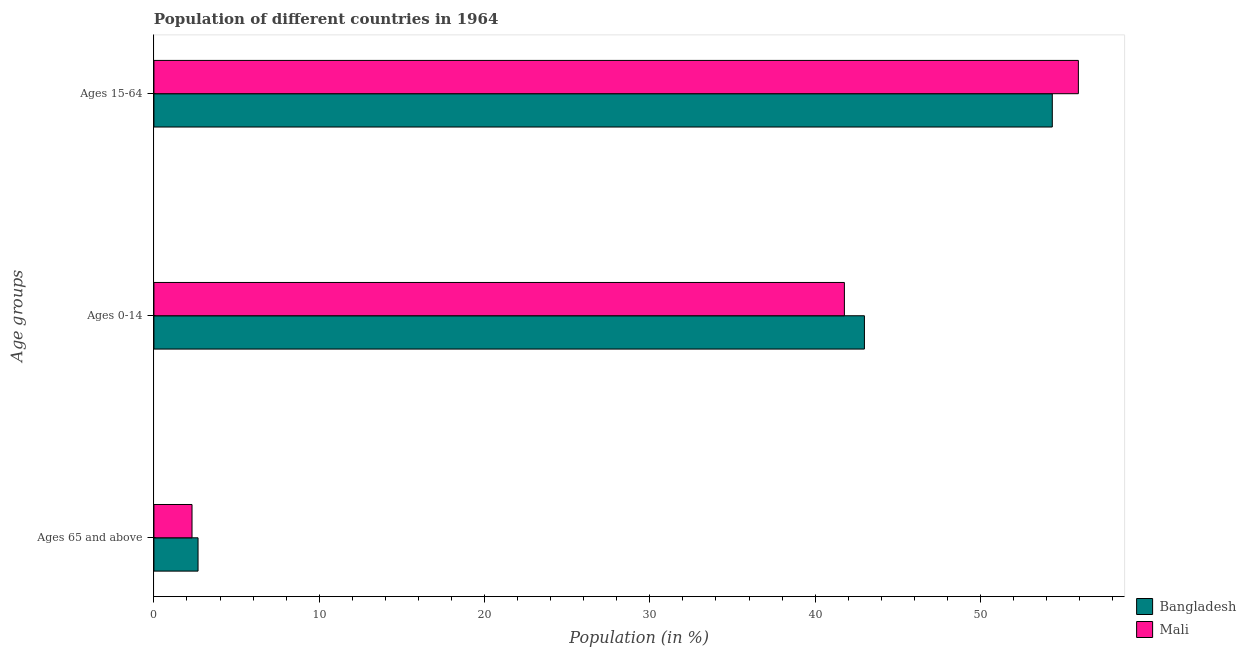Are the number of bars on each tick of the Y-axis equal?
Keep it short and to the point. Yes. How many bars are there on the 1st tick from the top?
Keep it short and to the point. 2. How many bars are there on the 2nd tick from the bottom?
Make the answer very short. 2. What is the label of the 1st group of bars from the top?
Offer a terse response. Ages 15-64. What is the percentage of population within the age-group 0-14 in Bangladesh?
Your answer should be very brief. 42.98. Across all countries, what is the maximum percentage of population within the age-group of 65 and above?
Your answer should be very brief. 2.67. Across all countries, what is the minimum percentage of population within the age-group of 65 and above?
Give a very brief answer. 2.3. In which country was the percentage of population within the age-group 0-14 maximum?
Keep it short and to the point. Bangladesh. What is the total percentage of population within the age-group 15-64 in the graph?
Ensure brevity in your answer.  110.27. What is the difference between the percentage of population within the age-group 0-14 in Mali and that in Bangladesh?
Provide a short and direct response. -1.21. What is the difference between the percentage of population within the age-group 15-64 in Mali and the percentage of population within the age-group 0-14 in Bangladesh?
Make the answer very short. 12.94. What is the average percentage of population within the age-group 15-64 per country?
Offer a terse response. 55.14. What is the difference between the percentage of population within the age-group 15-64 and percentage of population within the age-group of 65 and above in Bangladesh?
Provide a succinct answer. 51.68. What is the ratio of the percentage of population within the age-group of 65 and above in Mali to that in Bangladesh?
Your answer should be compact. 0.86. What is the difference between the highest and the second highest percentage of population within the age-group 0-14?
Provide a succinct answer. 1.21. What is the difference between the highest and the lowest percentage of population within the age-group 15-64?
Your answer should be very brief. 1.58. In how many countries, is the percentage of population within the age-group 0-14 greater than the average percentage of population within the age-group 0-14 taken over all countries?
Ensure brevity in your answer.  1. What does the 2nd bar from the top in Ages 15-64 represents?
Provide a short and direct response. Bangladesh. What does the 2nd bar from the bottom in Ages 0-14 represents?
Offer a terse response. Mali. Is it the case that in every country, the sum of the percentage of population within the age-group of 65 and above and percentage of population within the age-group 0-14 is greater than the percentage of population within the age-group 15-64?
Provide a succinct answer. No. How many bars are there?
Keep it short and to the point. 6. How many countries are there in the graph?
Provide a short and direct response. 2. Are the values on the major ticks of X-axis written in scientific E-notation?
Your answer should be very brief. No. How are the legend labels stacked?
Your answer should be very brief. Vertical. What is the title of the graph?
Give a very brief answer. Population of different countries in 1964. What is the label or title of the Y-axis?
Provide a succinct answer. Age groups. What is the Population (in %) of Bangladesh in Ages 65 and above?
Offer a very short reply. 2.67. What is the Population (in %) of Mali in Ages 65 and above?
Your answer should be compact. 2.3. What is the Population (in %) of Bangladesh in Ages 0-14?
Ensure brevity in your answer.  42.98. What is the Population (in %) in Mali in Ages 0-14?
Make the answer very short. 41.77. What is the Population (in %) of Bangladesh in Ages 15-64?
Your response must be concise. 54.35. What is the Population (in %) in Mali in Ages 15-64?
Your response must be concise. 55.93. Across all Age groups, what is the maximum Population (in %) in Bangladesh?
Ensure brevity in your answer.  54.35. Across all Age groups, what is the maximum Population (in %) of Mali?
Your answer should be very brief. 55.93. Across all Age groups, what is the minimum Population (in %) in Bangladesh?
Give a very brief answer. 2.67. Across all Age groups, what is the minimum Population (in %) in Mali?
Ensure brevity in your answer.  2.3. What is the total Population (in %) in Bangladesh in the graph?
Your answer should be compact. 100. What is the difference between the Population (in %) in Bangladesh in Ages 65 and above and that in Ages 0-14?
Your answer should be compact. -40.31. What is the difference between the Population (in %) in Mali in Ages 65 and above and that in Ages 0-14?
Your response must be concise. -39.47. What is the difference between the Population (in %) in Bangladesh in Ages 65 and above and that in Ages 15-64?
Your answer should be very brief. -51.68. What is the difference between the Population (in %) of Mali in Ages 65 and above and that in Ages 15-64?
Provide a succinct answer. -53.62. What is the difference between the Population (in %) in Bangladesh in Ages 0-14 and that in Ages 15-64?
Give a very brief answer. -11.37. What is the difference between the Population (in %) in Mali in Ages 0-14 and that in Ages 15-64?
Your answer should be compact. -14.16. What is the difference between the Population (in %) in Bangladesh in Ages 65 and above and the Population (in %) in Mali in Ages 0-14?
Keep it short and to the point. -39.1. What is the difference between the Population (in %) in Bangladesh in Ages 65 and above and the Population (in %) in Mali in Ages 15-64?
Offer a terse response. -53.26. What is the difference between the Population (in %) in Bangladesh in Ages 0-14 and the Population (in %) in Mali in Ages 15-64?
Your answer should be compact. -12.94. What is the average Population (in %) of Bangladesh per Age groups?
Make the answer very short. 33.33. What is the average Population (in %) in Mali per Age groups?
Your answer should be compact. 33.33. What is the difference between the Population (in %) in Bangladesh and Population (in %) in Mali in Ages 65 and above?
Your answer should be compact. 0.36. What is the difference between the Population (in %) of Bangladesh and Population (in %) of Mali in Ages 0-14?
Give a very brief answer. 1.21. What is the difference between the Population (in %) of Bangladesh and Population (in %) of Mali in Ages 15-64?
Make the answer very short. -1.58. What is the ratio of the Population (in %) of Bangladesh in Ages 65 and above to that in Ages 0-14?
Your answer should be compact. 0.06. What is the ratio of the Population (in %) of Mali in Ages 65 and above to that in Ages 0-14?
Provide a succinct answer. 0.06. What is the ratio of the Population (in %) of Bangladesh in Ages 65 and above to that in Ages 15-64?
Give a very brief answer. 0.05. What is the ratio of the Population (in %) in Mali in Ages 65 and above to that in Ages 15-64?
Offer a terse response. 0.04. What is the ratio of the Population (in %) of Bangladesh in Ages 0-14 to that in Ages 15-64?
Ensure brevity in your answer.  0.79. What is the ratio of the Population (in %) in Mali in Ages 0-14 to that in Ages 15-64?
Give a very brief answer. 0.75. What is the difference between the highest and the second highest Population (in %) in Bangladesh?
Keep it short and to the point. 11.37. What is the difference between the highest and the second highest Population (in %) in Mali?
Provide a short and direct response. 14.16. What is the difference between the highest and the lowest Population (in %) in Bangladesh?
Give a very brief answer. 51.68. What is the difference between the highest and the lowest Population (in %) of Mali?
Ensure brevity in your answer.  53.62. 